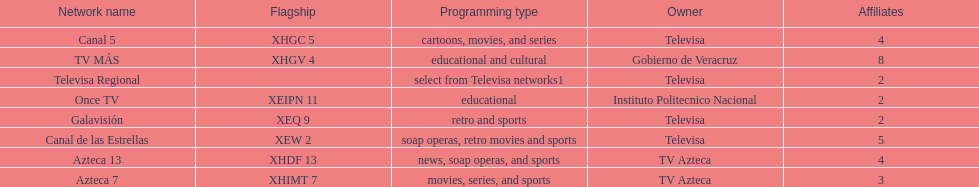Tell me the number of stations tv azteca owns. 2. 